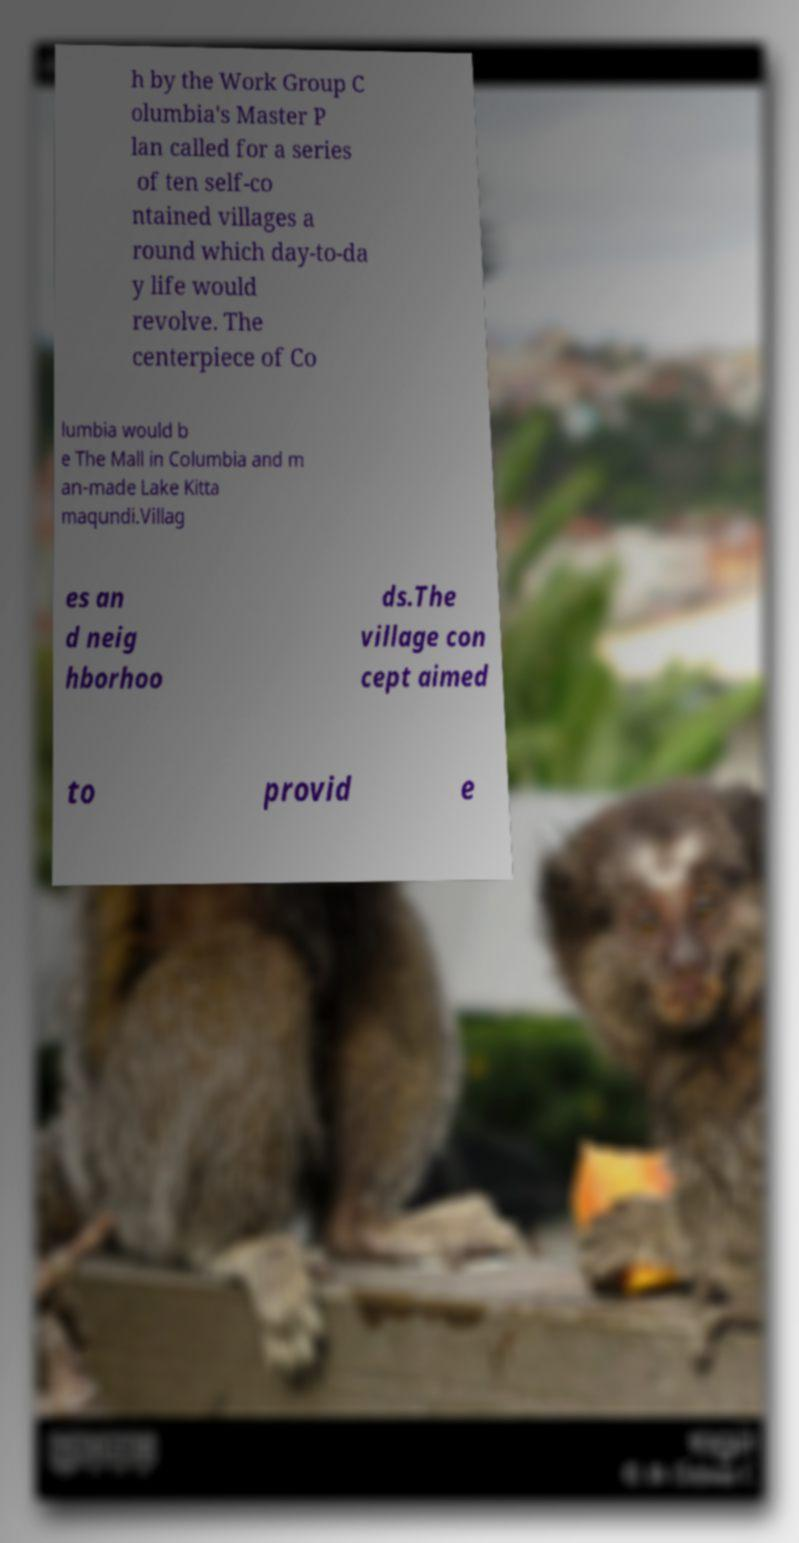Please read and relay the text visible in this image. What does it say? h by the Work Group C olumbia's Master P lan called for a series of ten self-co ntained villages a round which day-to-da y life would revolve. The centerpiece of Co lumbia would b e The Mall in Columbia and m an-made Lake Kitta maqundi.Villag es an d neig hborhoo ds.The village con cept aimed to provid e 